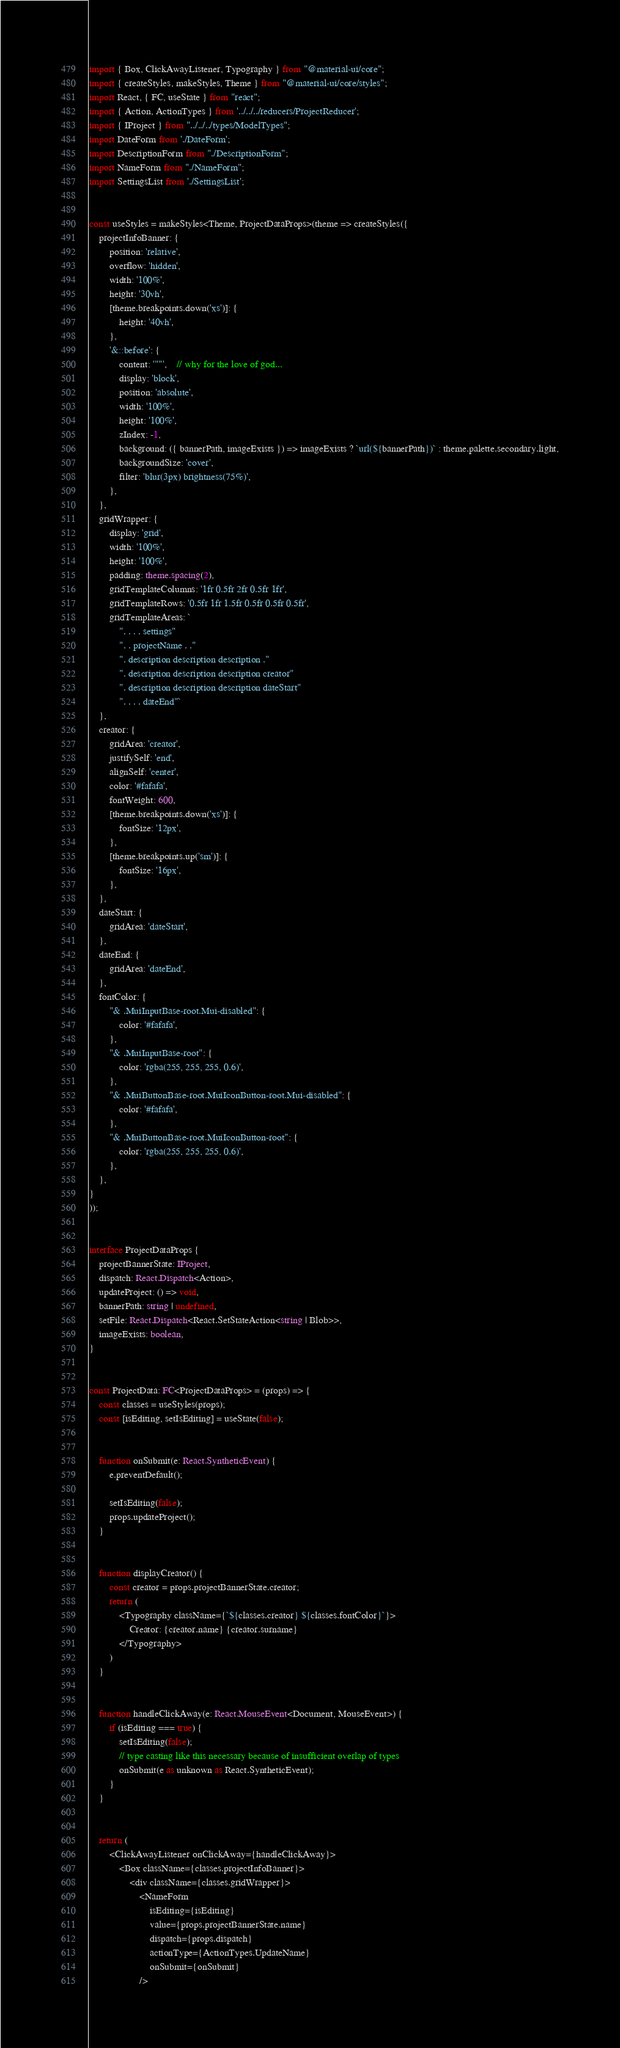<code> <loc_0><loc_0><loc_500><loc_500><_TypeScript_>import { Box, ClickAwayListener, Typography } from "@material-ui/core";
import { createStyles, makeStyles, Theme } from "@material-ui/core/styles";
import React, { FC, useState } from "react";
import { Action, ActionTypes } from '../../../reducers/ProjectReducer';
import { IProject } from "../../../types/ModelTypes";
import DateForm from './DateForm';
import DescriptionForm from "./DescriptionForm";
import NameForm from "./NameForm";
import SettingsList from './SettingsList';


const useStyles = makeStyles<Theme, ProjectDataProps>(theme => createStyles({
	projectInfoBanner: {
		position: 'relative',
		overflow: 'hidden',
		width: '100%',
		height: '30vh',
		[theme.breakpoints.down('xs')]: {
			height: '40vh',
		},
		'&::before': {
			content: '""',    // why for the love of god...
			display: 'block',
			position: 'absolute',
			width: '100%',
			height: '100%',
			zIndex: -1,
			background: ({ bannerPath, imageExists }) => imageExists ? `url(${bannerPath})` : theme.palette.secondary.light,
			backgroundSize: 'cover',
			filter: 'blur(3px) brightness(75%)',
		},
	},
	gridWrapper: {
		display: 'grid',
		width: '100%',
		height: '100%',
		padding: theme.spacing(2),
		gridTemplateColumns: '1fr 0.5fr 2fr 0.5fr 1fr',
		gridTemplateRows: '0.5fr 1fr 1.5fr 0.5fr 0.5fr 0.5fr',
		gridTemplateAreas: `
			". . . . settings"
			". . projectName . ."
			". description description description ."
			". description description description creator"
			". description description description dateStart"
			". . . . dateEnd"`
	},
	creator: {
		gridArea: 'creator',
		justifySelf: 'end',
		alignSelf: 'center',
		color: '#fafafa',
		fontWeight: 600,
		[theme.breakpoints.down('xs')]: {
			fontSize: '12px',
		},
		[theme.breakpoints.up('sm')]: {
			fontSize: '16px',
		},
	},
	dateStart: {
		gridArea: 'dateStart',
	},
	dateEnd: {
		gridArea: 'dateEnd',
	},
	fontColor: {
		"& .MuiInputBase-root.Mui-disabled": {
			color: '#fafafa',
		},
		"& .MuiInputBase-root": {
			color: 'rgba(255, 255, 255, 0.6)',
		},
		"& .MuiButtonBase-root.MuiIconButton-root.Mui-disabled": {
			color: '#fafafa',
		},
		"& .MuiButtonBase-root.MuiIconButton-root": {
			color: 'rgba(255, 255, 255, 0.6)',
		},
	},
}
));


interface ProjectDataProps {
	projectBannerState: IProject,
	dispatch: React.Dispatch<Action>,
	updateProject: () => void,
	bannerPath: string | undefined,
	setFile: React.Dispatch<React.SetStateAction<string | Blob>>,
	imageExists: boolean,
}


const ProjectData: FC<ProjectDataProps> = (props) => {
	const classes = useStyles(props);
	const [isEditing, setIsEditing] = useState(false);


	function onSubmit(e: React.SyntheticEvent) {
		e.preventDefault();

		setIsEditing(false);
		props.updateProject();
	}


	function displayCreator() {
		const creator = props.projectBannerState.creator;
		return (
			<Typography className={`${classes.creator} ${classes.fontColor}`}>
				Creator: {creator.name} {creator.surname}
			</Typography>
		)
	}


	function handleClickAway(e: React.MouseEvent<Document, MouseEvent>) {
		if (isEditing === true) {
			setIsEditing(false);
			// type casting like this necessary because of insufficient overlap of types
			onSubmit(e as unknown as React.SyntheticEvent);
		}
	}


	return (
		<ClickAwayListener onClickAway={handleClickAway}>
			<Box className={classes.projectInfoBanner}>
				<div className={classes.gridWrapper}>
					<NameForm
						isEditing={isEditing}
						value={props.projectBannerState.name}
						dispatch={props.dispatch}
						actionType={ActionTypes.UpdateName}
						onSubmit={onSubmit}
					/>
</code> 